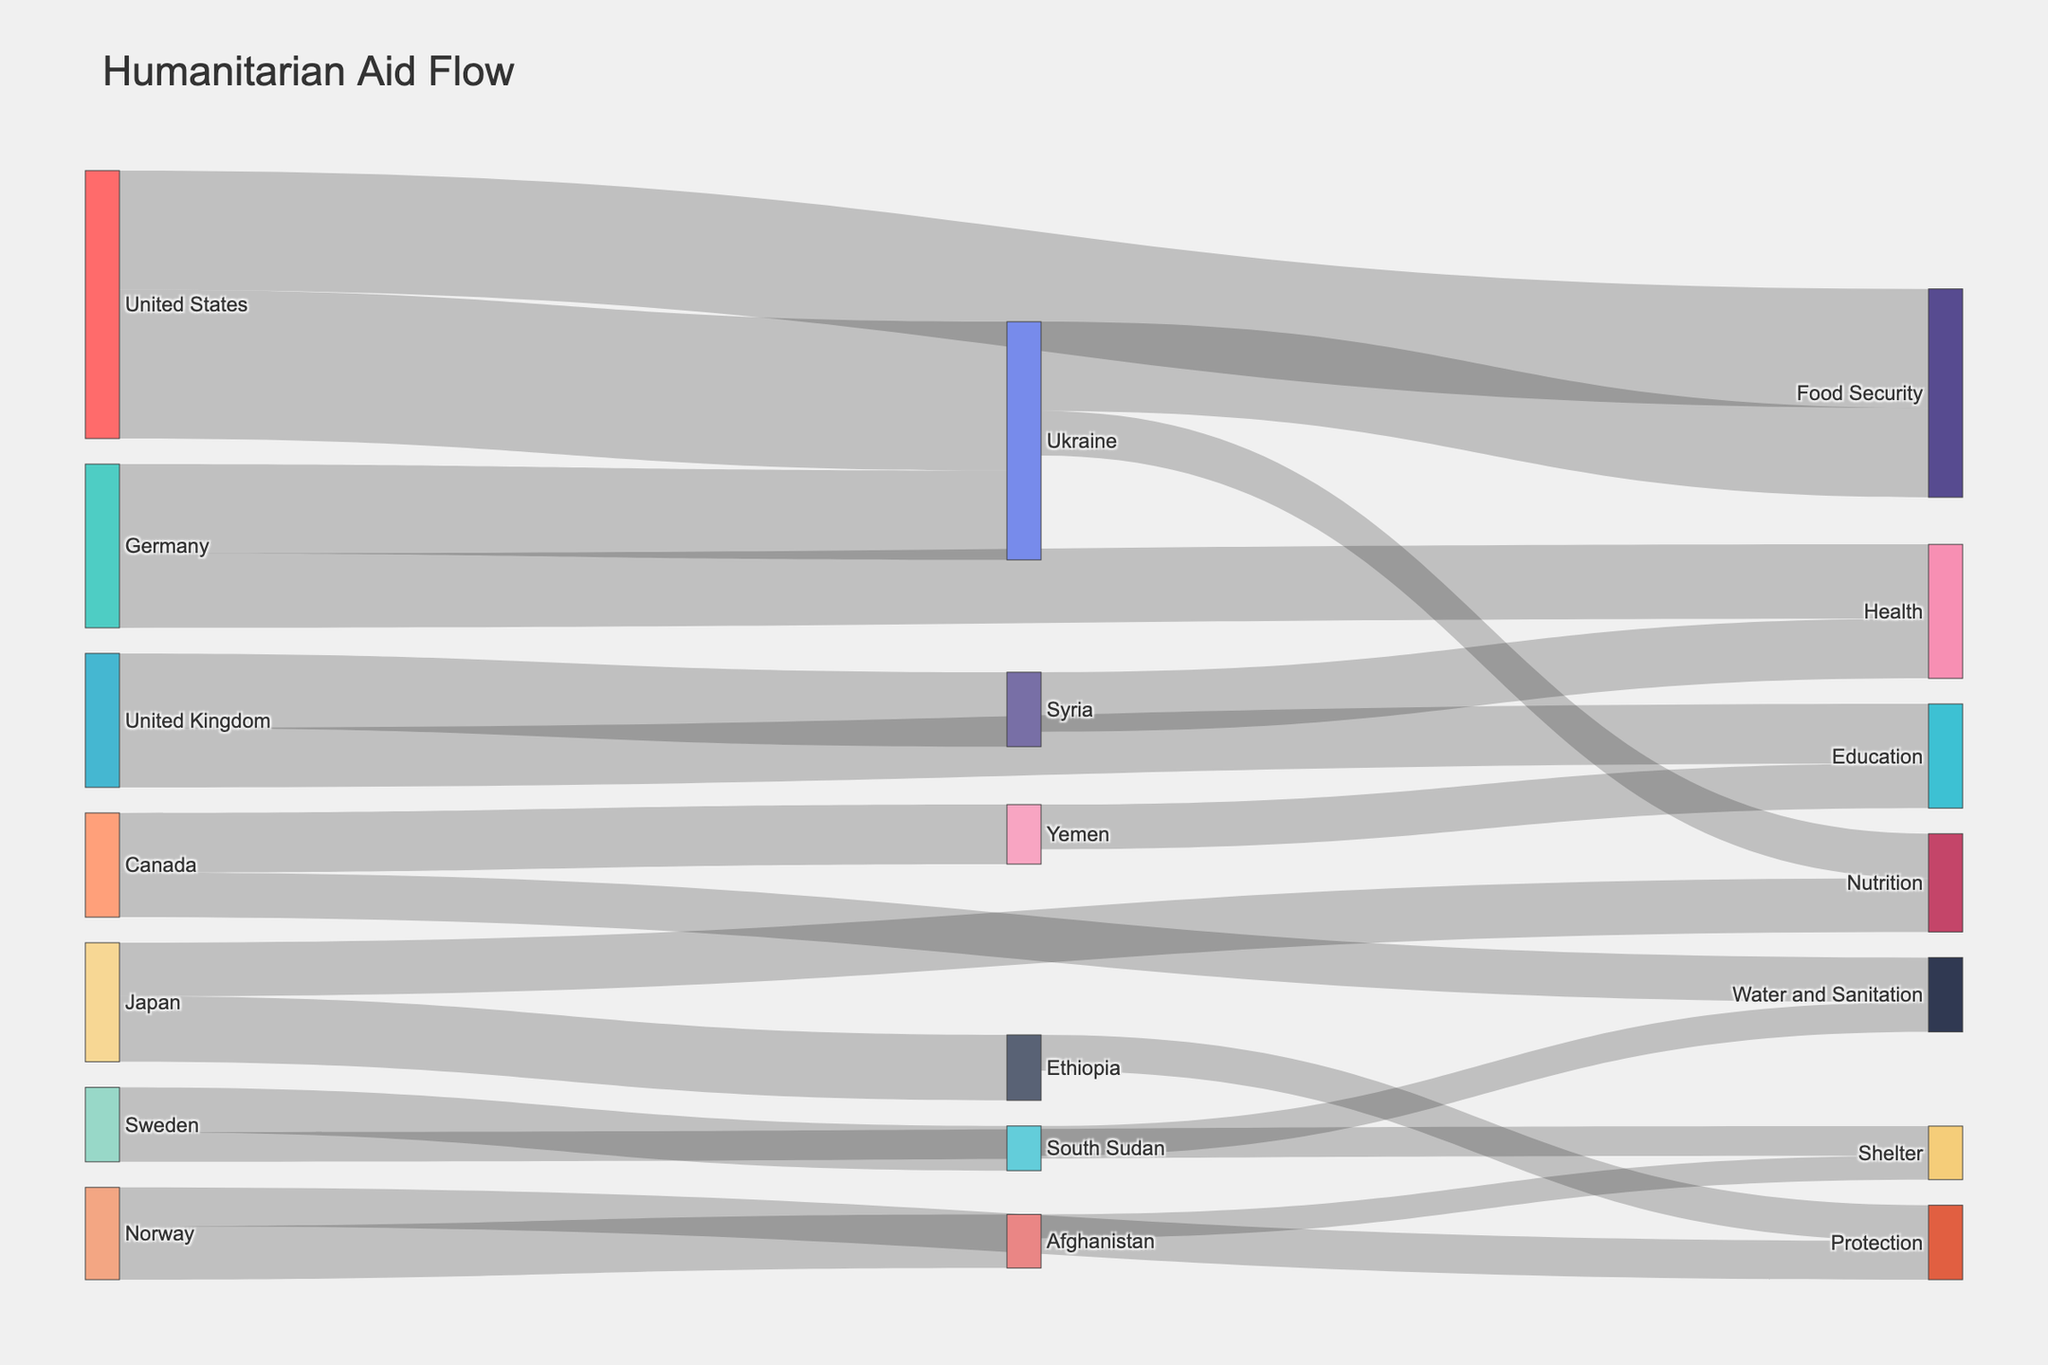What is the title of the plot? The title is usually located at the top of the plot and provides an overview of what the plot is about. In this case, it's "Humanitarian Aid Flow" indicating the movement of aid from donor countries to recipient nations and sectors.
Answer: Humanitarian Aid Flow Which country contributed the most humanitarian aid to Ukraine? Examine the links on the plot connected to Ukraine, identify the country with the largest aid flow. The United States has a flow value of 500, which is the highest.
Answer: United States How much aid did Japan donate in total? Sum the values of aid donations from Japan, which are split between two targets: Ethiopia (220) and Nutrition (180). Therefore, 220 + 180 = 400.
Answer: 400 Which sector received the least aid from donor countries? Look at the sectors at the right side of the Sankey Diagram and compare their values. Shelter received the least aid with 100.
Answer: Shelter How much aid did Ukraine receive overall? Combine the aid values Ukraine received directly (500 from the United States, 300 from Germany) and from sectors: 300 from Food Security and 150 from Nutrition. So, 500 + 300 + 300 + 150 = 1250.
Answer: 1250 Compare the aid received by Syria and Yemen. Which received more and by how much? Check the flows towards Syria and Yemen. Syria received 250 (from the UK) and 200 (from Health), totaling 450. Yemen received 200 (from Canada) and 150 (from Education), totaling 350. Syria received more aid by 450 - 350 = 100.
Answer: Syria by 100 Which donor countries contributed to the Food Security sector? Trace the links connected to the Food Security sector. The United States and Ukraine contributed to it with values of 400 and 300 respectively.
Answer: United States and Ukraine How many unique sectors are represented in the Sankey Diagram? Count the unique sectors on the diagram: Food Security, Health, Education, Water and Sanitation, Shelter, Protection, Nutrition. There are 7 sectors.
Answer: 7 What is the total amount of humanitarian aid represented in the diagram? Sum all the aid values in the dataset: 500 + 300 + 250 + 200 + 150 + 180 + 220 + 400 + 250 + 200 + 150 + 100 + 130 + 180 + 300 + 200 + 150 + 100 + 80 + 120 + 150 = 4430.
Answer: 4430 